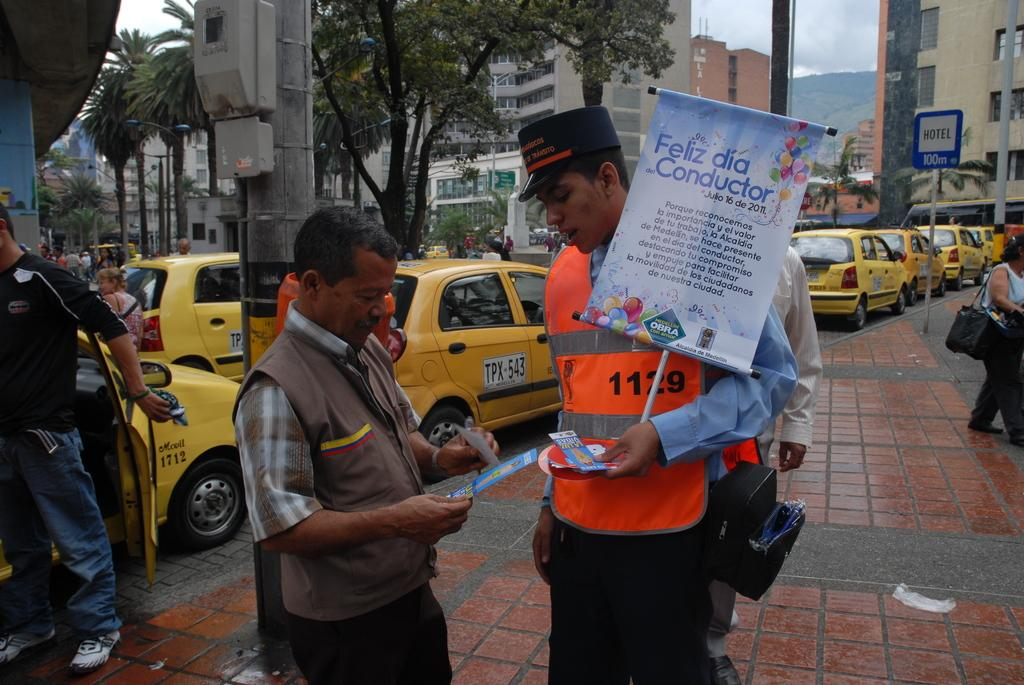<image>
Summarize the visual content of the image. A man in an orange vest is carrying a sign that says, 'Feliz dia Conductor', is talking to another man in front of a line of yellow taxi cabs. 